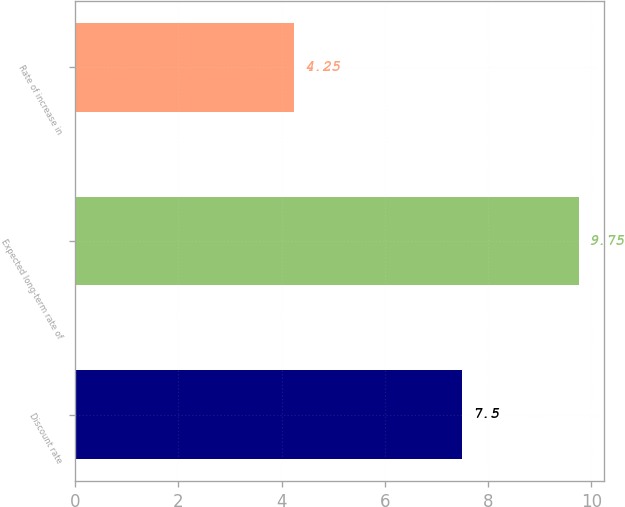<chart> <loc_0><loc_0><loc_500><loc_500><bar_chart><fcel>Discount rate<fcel>Expected long-term rate of<fcel>Rate of increase in<nl><fcel>7.5<fcel>9.75<fcel>4.25<nl></chart> 